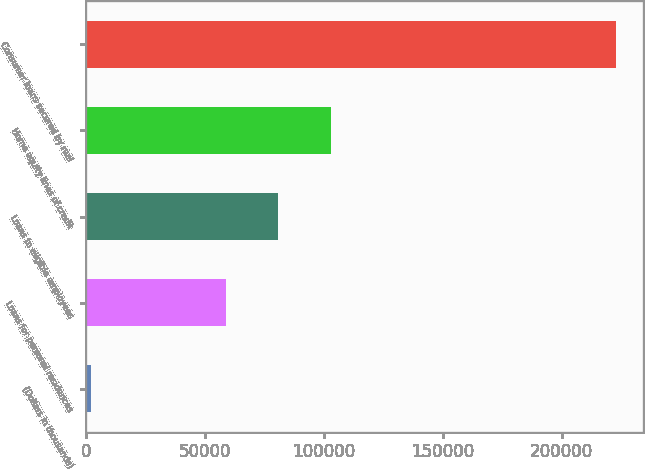Convert chart. <chart><loc_0><loc_0><loc_500><loc_500><bar_chart><fcel>(Dollars in thousands)<fcel>Loans for personal residences<fcel>Loans to eligible employees<fcel>Home equity lines of credit<fcel>Consumer loans secured by real<nl><fcel>2008<fcel>58702<fcel>80802.4<fcel>102903<fcel>223012<nl></chart> 